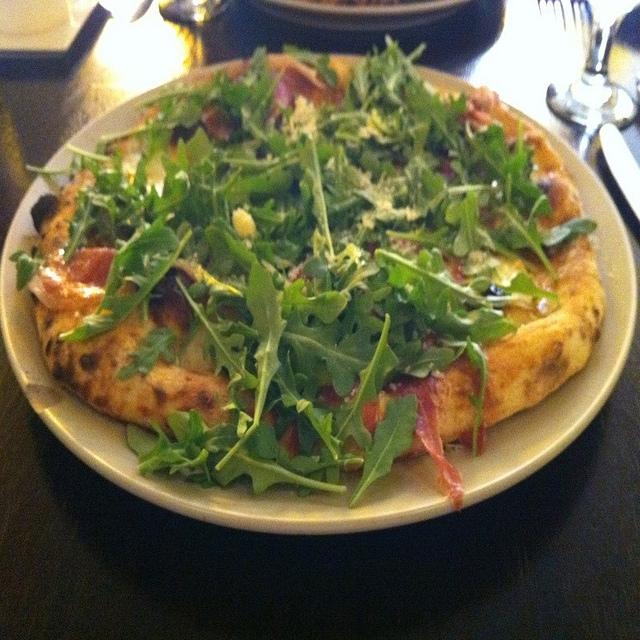What color is the table?
Give a very brief answer. Black. What color is the plate?
Give a very brief answer. White. What is the green leafy topping of the pizza?
Keep it brief. Lettuce. Is this meal edible for someone without teeth?
Concise answer only. No. 